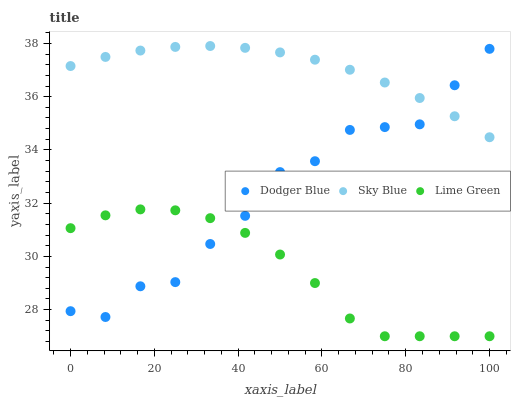Does Lime Green have the minimum area under the curve?
Answer yes or no. Yes. Does Sky Blue have the maximum area under the curve?
Answer yes or no. Yes. Does Dodger Blue have the minimum area under the curve?
Answer yes or no. No. Does Dodger Blue have the maximum area under the curve?
Answer yes or no. No. Is Sky Blue the smoothest?
Answer yes or no. Yes. Is Dodger Blue the roughest?
Answer yes or no. Yes. Is Lime Green the smoothest?
Answer yes or no. No. Is Lime Green the roughest?
Answer yes or no. No. Does Lime Green have the lowest value?
Answer yes or no. Yes. Does Dodger Blue have the lowest value?
Answer yes or no. No. Does Sky Blue have the highest value?
Answer yes or no. Yes. Does Dodger Blue have the highest value?
Answer yes or no. No. Is Lime Green less than Sky Blue?
Answer yes or no. Yes. Is Sky Blue greater than Lime Green?
Answer yes or no. Yes. Does Dodger Blue intersect Lime Green?
Answer yes or no. Yes. Is Dodger Blue less than Lime Green?
Answer yes or no. No. Is Dodger Blue greater than Lime Green?
Answer yes or no. No. Does Lime Green intersect Sky Blue?
Answer yes or no. No. 